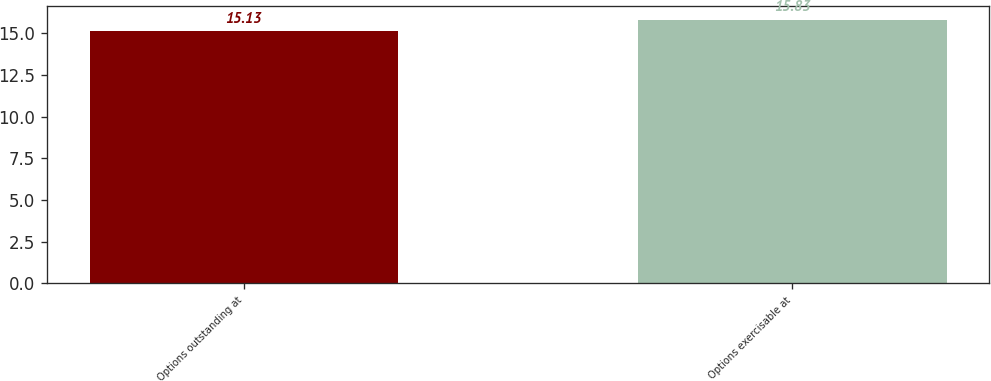Convert chart to OTSL. <chart><loc_0><loc_0><loc_500><loc_500><bar_chart><fcel>Options outstanding at<fcel>Options exercisable at<nl><fcel>15.13<fcel>15.83<nl></chart> 